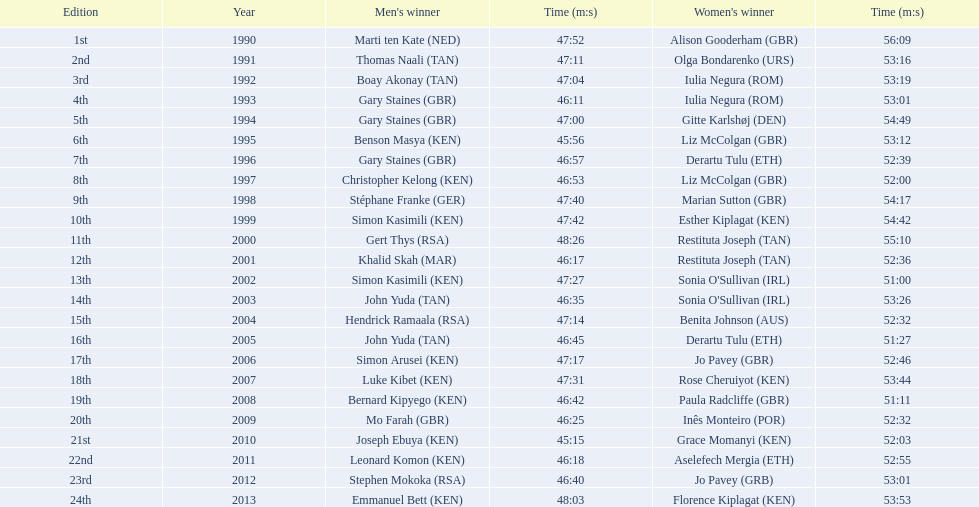Which of the runner in the great south run were women? Alison Gooderham (GBR), Olga Bondarenko (URS), Iulia Negura (ROM), Iulia Negura (ROM), Gitte Karlshøj (DEN), Liz McColgan (GBR), Derartu Tulu (ETH), Liz McColgan (GBR), Marian Sutton (GBR), Esther Kiplagat (KEN), Restituta Joseph (TAN), Restituta Joseph (TAN), Sonia O'Sullivan (IRL), Sonia O'Sullivan (IRL), Benita Johnson (AUS), Derartu Tulu (ETH), Jo Pavey (GBR), Rose Cheruiyot (KEN), Paula Radcliffe (GBR), Inês Monteiro (POR), Grace Momanyi (KEN), Aselefech Mergia (ETH), Jo Pavey (GRB), Florence Kiplagat (KEN). Of those women, which ones had a time of at least 53 minutes? Alison Gooderham (GBR), Olga Bondarenko (URS), Iulia Negura (ROM), Iulia Negura (ROM), Gitte Karlshøj (DEN), Liz McColgan (GBR), Marian Sutton (GBR), Esther Kiplagat (KEN), Restituta Joseph (TAN), Sonia O'Sullivan (IRL), Rose Cheruiyot (KEN), Jo Pavey (GRB), Florence Kiplagat (KEN). Between those women, which ones did not go over 53 minutes? Olga Bondarenko (URS), Iulia Negura (ROM), Iulia Negura (ROM), Liz McColgan (GBR), Sonia O'Sullivan (IRL), Rose Cheruiyot (KEN), Jo Pavey (GRB), Florence Kiplagat (KEN). Of those 8, what were the three slowest times? Sonia O'Sullivan (IRL), Rose Cheruiyot (KEN), Florence Kiplagat (KEN). Between only those 3 women, which runner had the fastest time? Sonia O'Sullivan (IRL). What was this women's time? 53:26. 